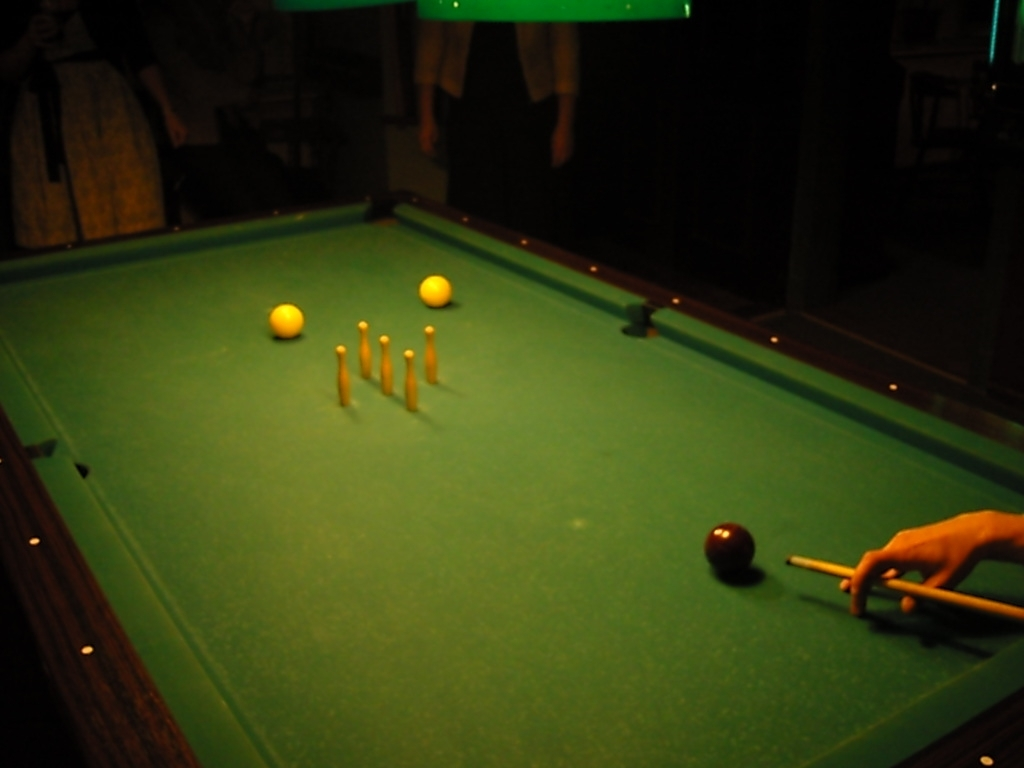Can you describe the atmosphere or setting surrounding the pool table? The setting around the table feels casual and relaxed, typical of a social gathering spot or a domestic game room. The ambient lighting is subdued with a focus on the table itself. There appears to be a group of people nearby, suggesting that this is a shared activity with onlookers or players waiting for their turn. 